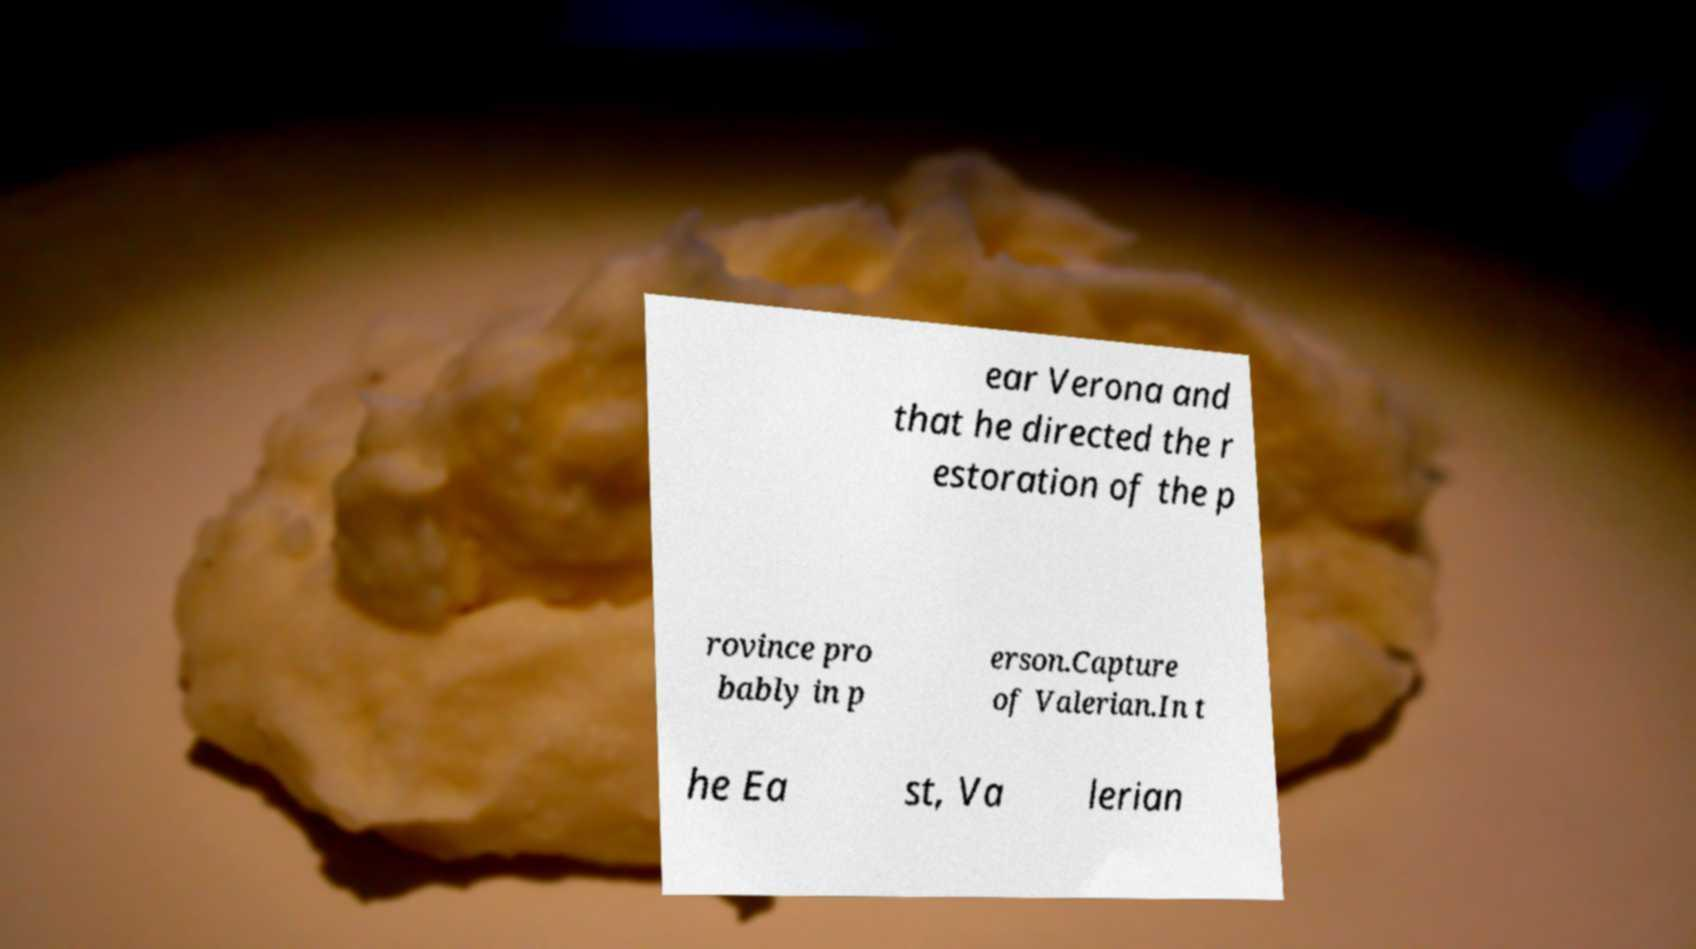I need the written content from this picture converted into text. Can you do that? ear Verona and that he directed the r estoration of the p rovince pro bably in p erson.Capture of Valerian.In t he Ea st, Va lerian 